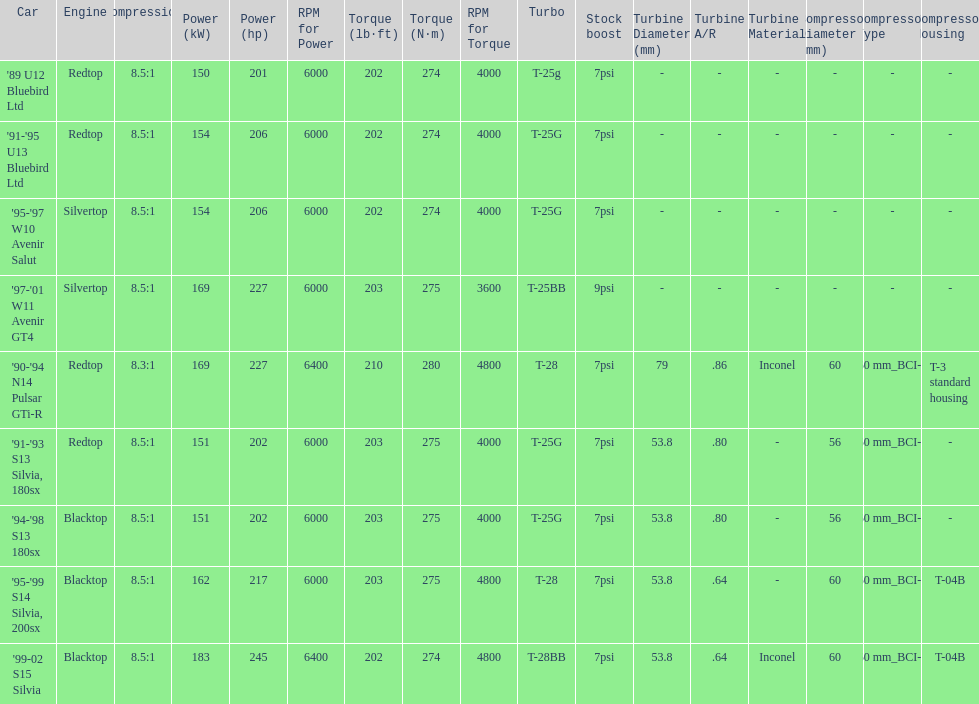Which engine has the smallest compression rate? '90-'94 N14 Pulsar GTi-R. 